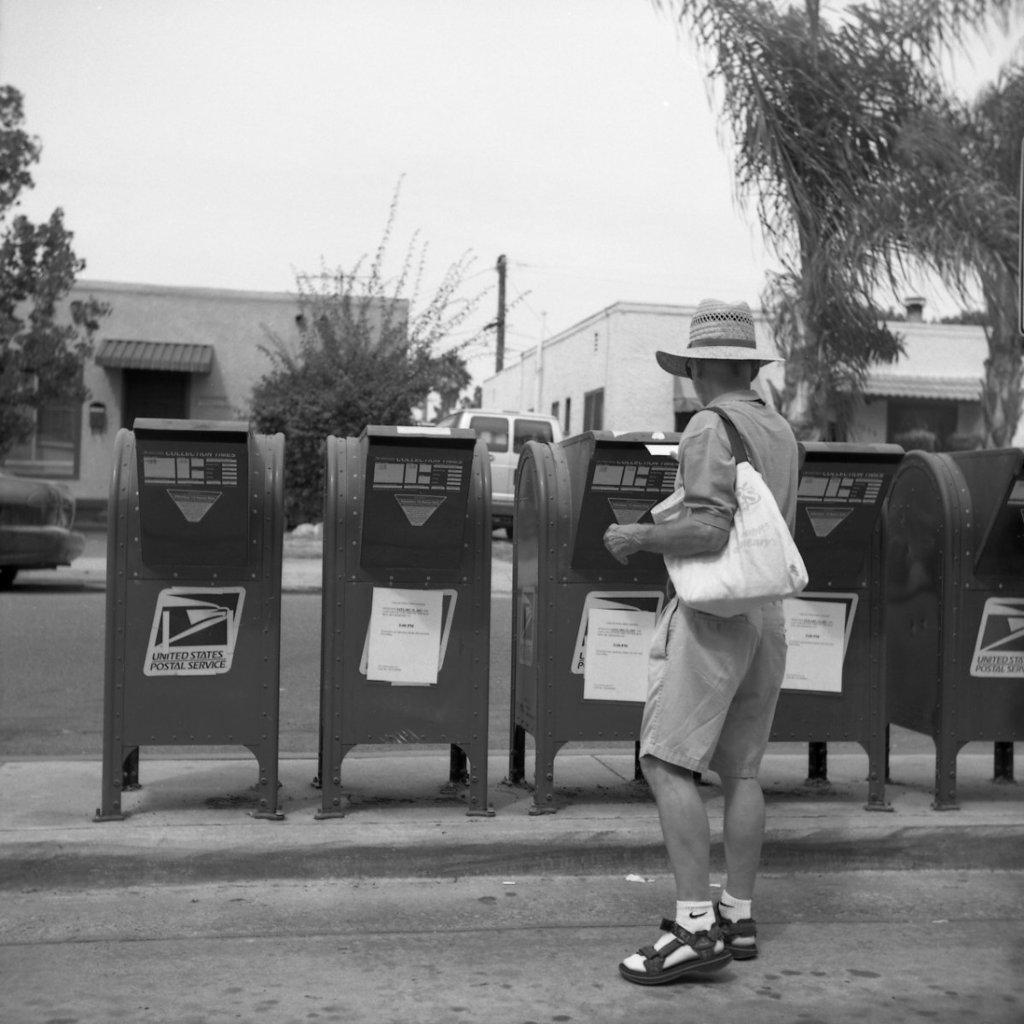<image>
Create a compact narrative representing the image presented. A person adding something to a post office box from the USPS. 